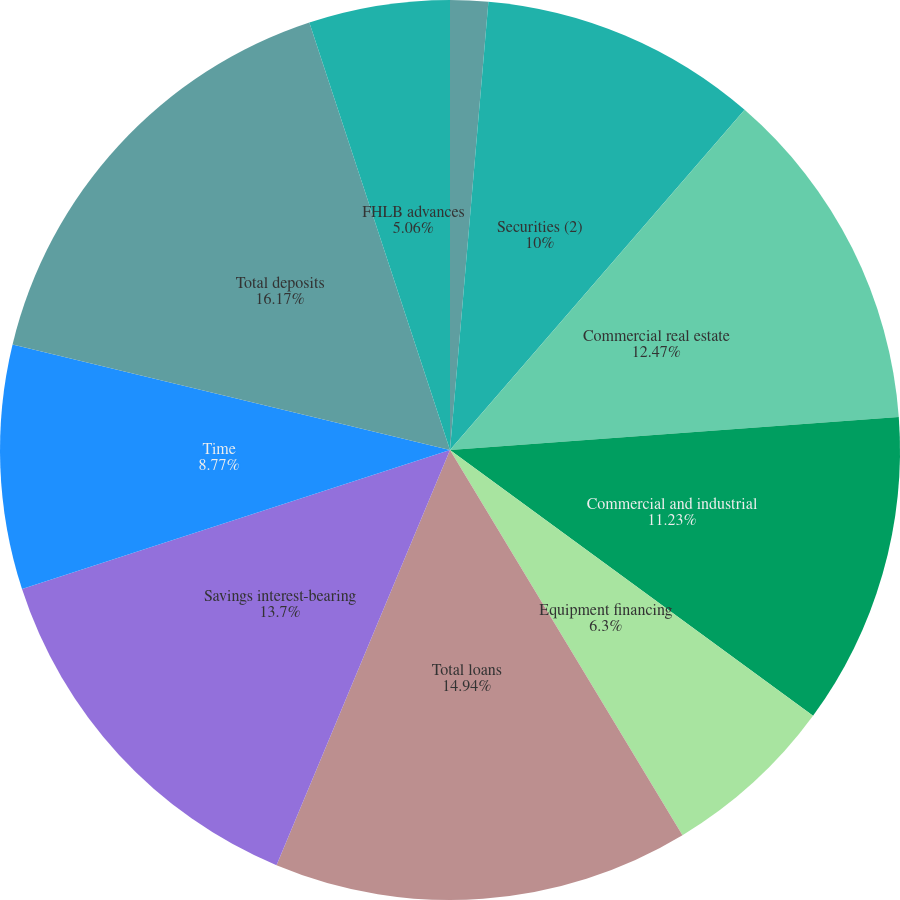<chart> <loc_0><loc_0><loc_500><loc_500><pie_chart><fcel>Short-term investments (1)<fcel>Securities (2)<fcel>Commercial real estate<fcel>Commercial and industrial<fcel>Equipment financing<fcel>Total loans<fcel>Savings interest-bearing<fcel>Time<fcel>Total deposits<fcel>FHLB advances<nl><fcel>1.36%<fcel>10.0%<fcel>12.47%<fcel>11.23%<fcel>6.3%<fcel>14.94%<fcel>13.7%<fcel>8.77%<fcel>16.17%<fcel>5.06%<nl></chart> 